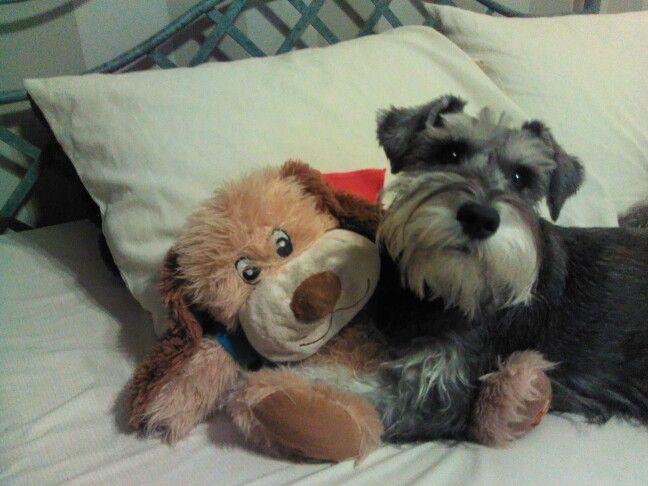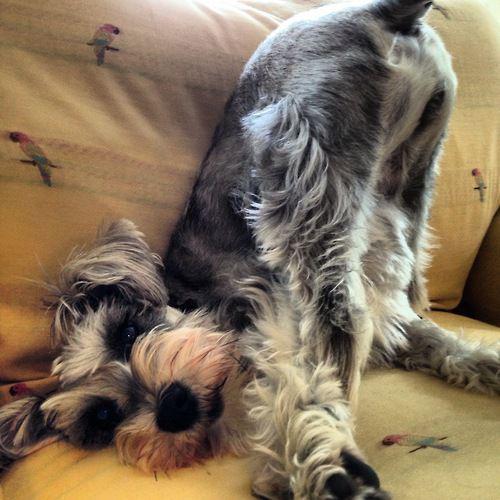The first image is the image on the left, the second image is the image on the right. For the images displayed, is the sentence "Each image contains one schnauzer posed on a piece of soft furniture." factually correct? Answer yes or no. Yes. The first image is the image on the left, the second image is the image on the right. Evaluate the accuracy of this statement regarding the images: "A dog is lying down on a white bed sheet in the left image.". Is it true? Answer yes or no. Yes. 